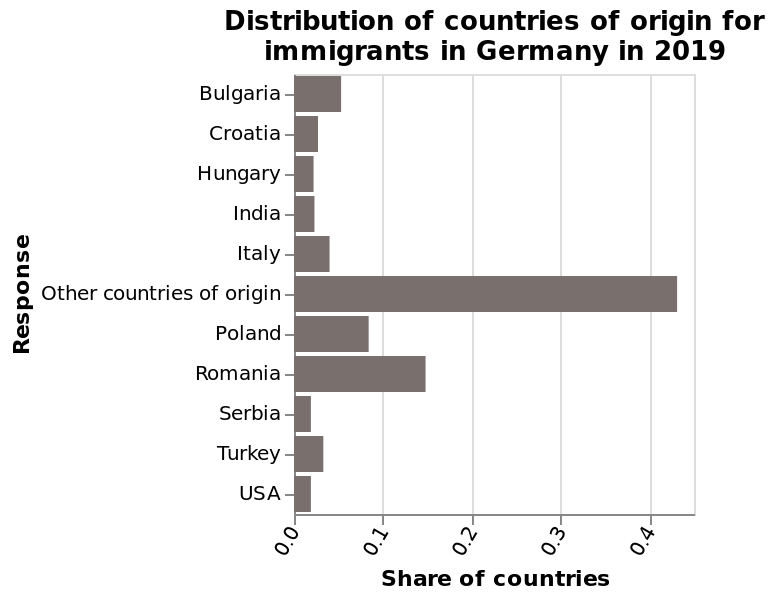<image>
What does the x-axis plot in the bar diagram?  The x-axis plots the share of countries on a linear scale from 0.0 to 0.4. What does the bar diagram represent?  The bar diagram represents the distribution of countries of origin for immigrants in Germany in 2019. 